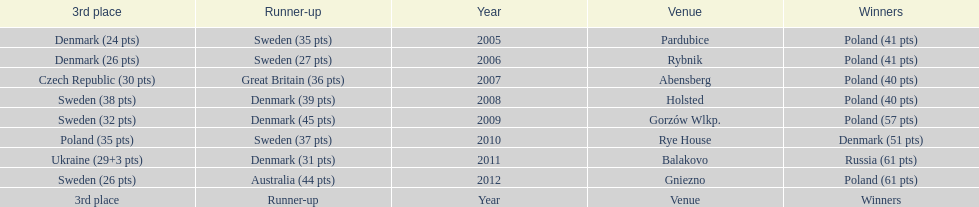Could you parse the entire table? {'header': ['3rd place', 'Runner-up', 'Year', 'Venue', 'Winners'], 'rows': [['Denmark (24 pts)', 'Sweden (35 pts)', '2005', 'Pardubice', 'Poland (41 pts)'], ['Denmark (26 pts)', 'Sweden (27 pts)', '2006', 'Rybnik', 'Poland (41 pts)'], ['Czech Republic (30 pts)', 'Great Britain (36 pts)', '2007', 'Abensberg', 'Poland (40 pts)'], ['Sweden (38 pts)', 'Denmark (39 pts)', '2008', 'Holsted', 'Poland (40 pts)'], ['Sweden (32 pts)', 'Denmark (45 pts)', '2009', 'Gorzów Wlkp.', 'Poland (57 pts)'], ['Poland (35 pts)', 'Sweden (37 pts)', '2010', 'Rye House', 'Denmark (51 pts)'], ['Ukraine (29+3 pts)', 'Denmark (31 pts)', '2011', 'Balakovo', 'Russia (61 pts)'], ['Sweden (26 pts)', 'Australia (44 pts)', '2012', 'Gniezno', 'Poland (61 pts)'], ['3rd place', 'Runner-up', 'Year', 'Venue', 'Winners']]} What was the difference in final score between russia and denmark in 2011? 30. 